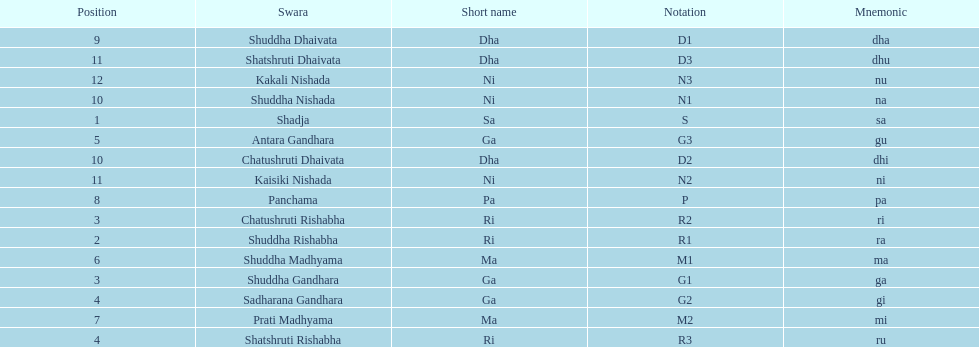What is the name of the swara that holds the first position? Shadja. 